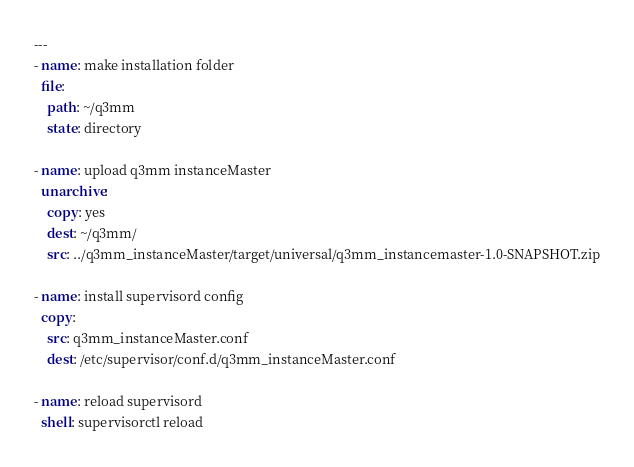<code> <loc_0><loc_0><loc_500><loc_500><_YAML_>---
- name: make installation folder
  file:
    path: ~/q3mm
    state: directory

- name: upload q3mm instanceMaster
  unarchive:
    copy: yes
    dest: ~/q3mm/
    src: ../q3mm_instanceMaster/target/universal/q3mm_instancemaster-1.0-SNAPSHOT.zip

- name: install supervisord config
  copy:
    src: q3mm_instanceMaster.conf
    dest: /etc/supervisor/conf.d/q3mm_instanceMaster.conf

- name: reload supervisord
  shell: supervisorctl reload
</code> 